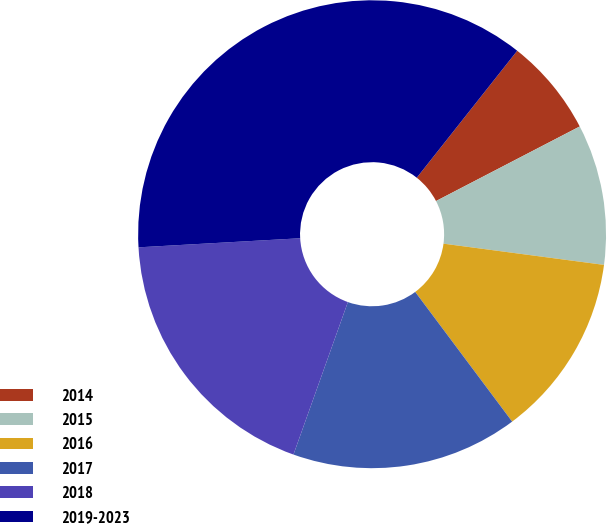Convert chart to OTSL. <chart><loc_0><loc_0><loc_500><loc_500><pie_chart><fcel>2014<fcel>2015<fcel>2016<fcel>2017<fcel>2018<fcel>2019-2023<nl><fcel>6.73%<fcel>9.71%<fcel>12.69%<fcel>15.67%<fcel>18.65%<fcel>36.54%<nl></chart> 